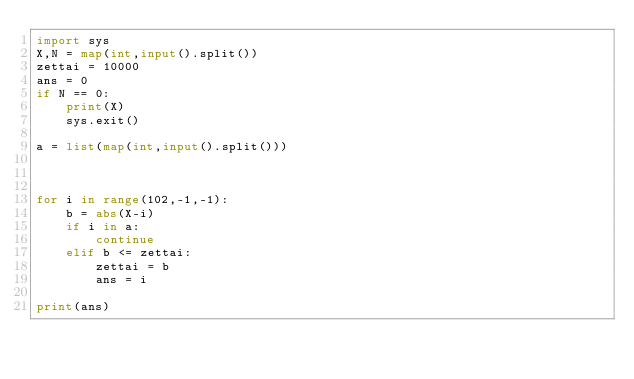<code> <loc_0><loc_0><loc_500><loc_500><_Python_>import sys
X,N = map(int,input().split())
zettai = 10000
ans = 0
if N == 0:
    print(X)
    sys.exit()
    
a = list(map(int,input().split()))



for i in range(102,-1,-1):
    b = abs(X-i)
    if i in a:
        continue
    elif b <= zettai:
        zettai = b
        ans = i

print(ans)
</code> 